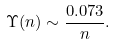<formula> <loc_0><loc_0><loc_500><loc_500>\Upsilon ( n ) \sim \frac { 0 . 0 7 3 } { n } .</formula> 